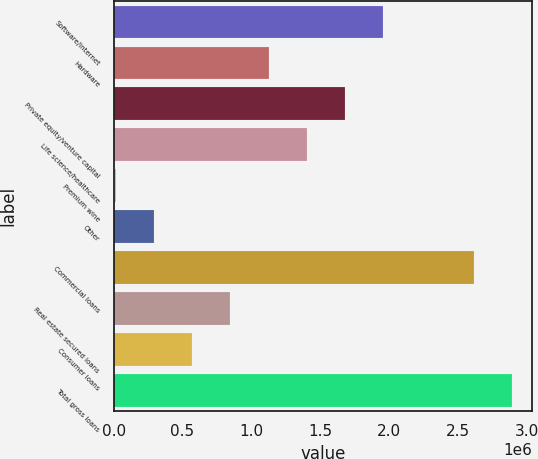<chart> <loc_0><loc_0><loc_500><loc_500><bar_chart><fcel>Software/internet<fcel>Hardware<fcel>Private equity/venture capital<fcel>Life science/healthcare<fcel>Premium wine<fcel>Other<fcel>Commercial loans<fcel>Real estate secured loans<fcel>Consumer loans<fcel>Total gross loans<nl><fcel>1.95783e+06<fcel>1.12557e+06<fcel>1.68041e+06<fcel>1.40299e+06<fcel>15902<fcel>293320<fcel>2.61819e+06<fcel>848156<fcel>570738<fcel>2.89561e+06<nl></chart> 